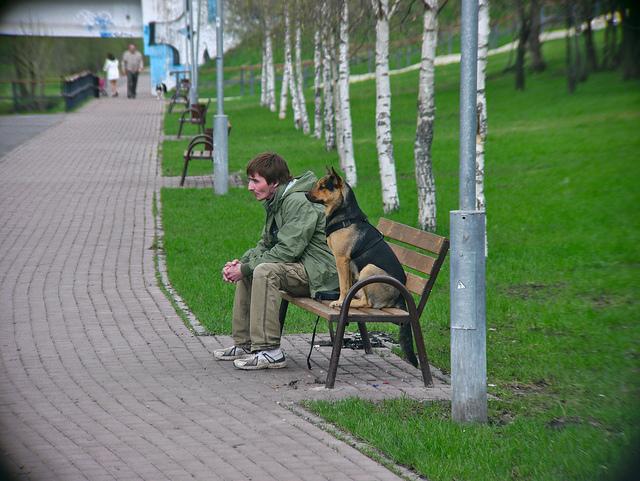How many dogs are shown?
Concise answer only. 1. How many people are shown?
Write a very short answer. 3. What type of dog is in the image?
Quick response, please. German shepherd. Is the man homeless?
Quick response, please. No. Does it appear to be warm in the park?
Quick response, please. No. What is next to the dog?
Short answer required. Man. Is this animal outside?
Be succinct. Yes. What color is the bench?
Answer briefly. Brown. 